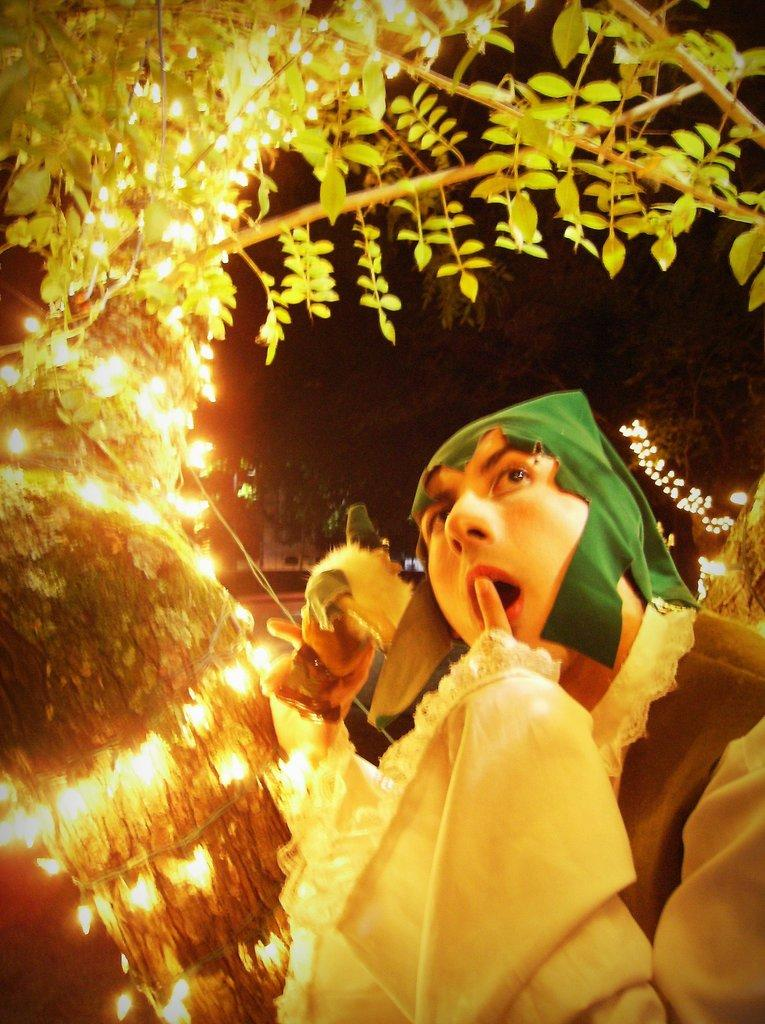What is hanging from the branch in the image? There is a branch with lights in the image. Can you describe the person in the image? There is a person in the bottom right of the image, and they are wearing clothes. What type of plane can be seen flying in the image? There is no plane visible in the image; it only features a branch with lights and a person. What kind of pleasure can be derived from the image? The image does not convey a specific pleasure or emotion; it simply shows a branch with lights and a person. 